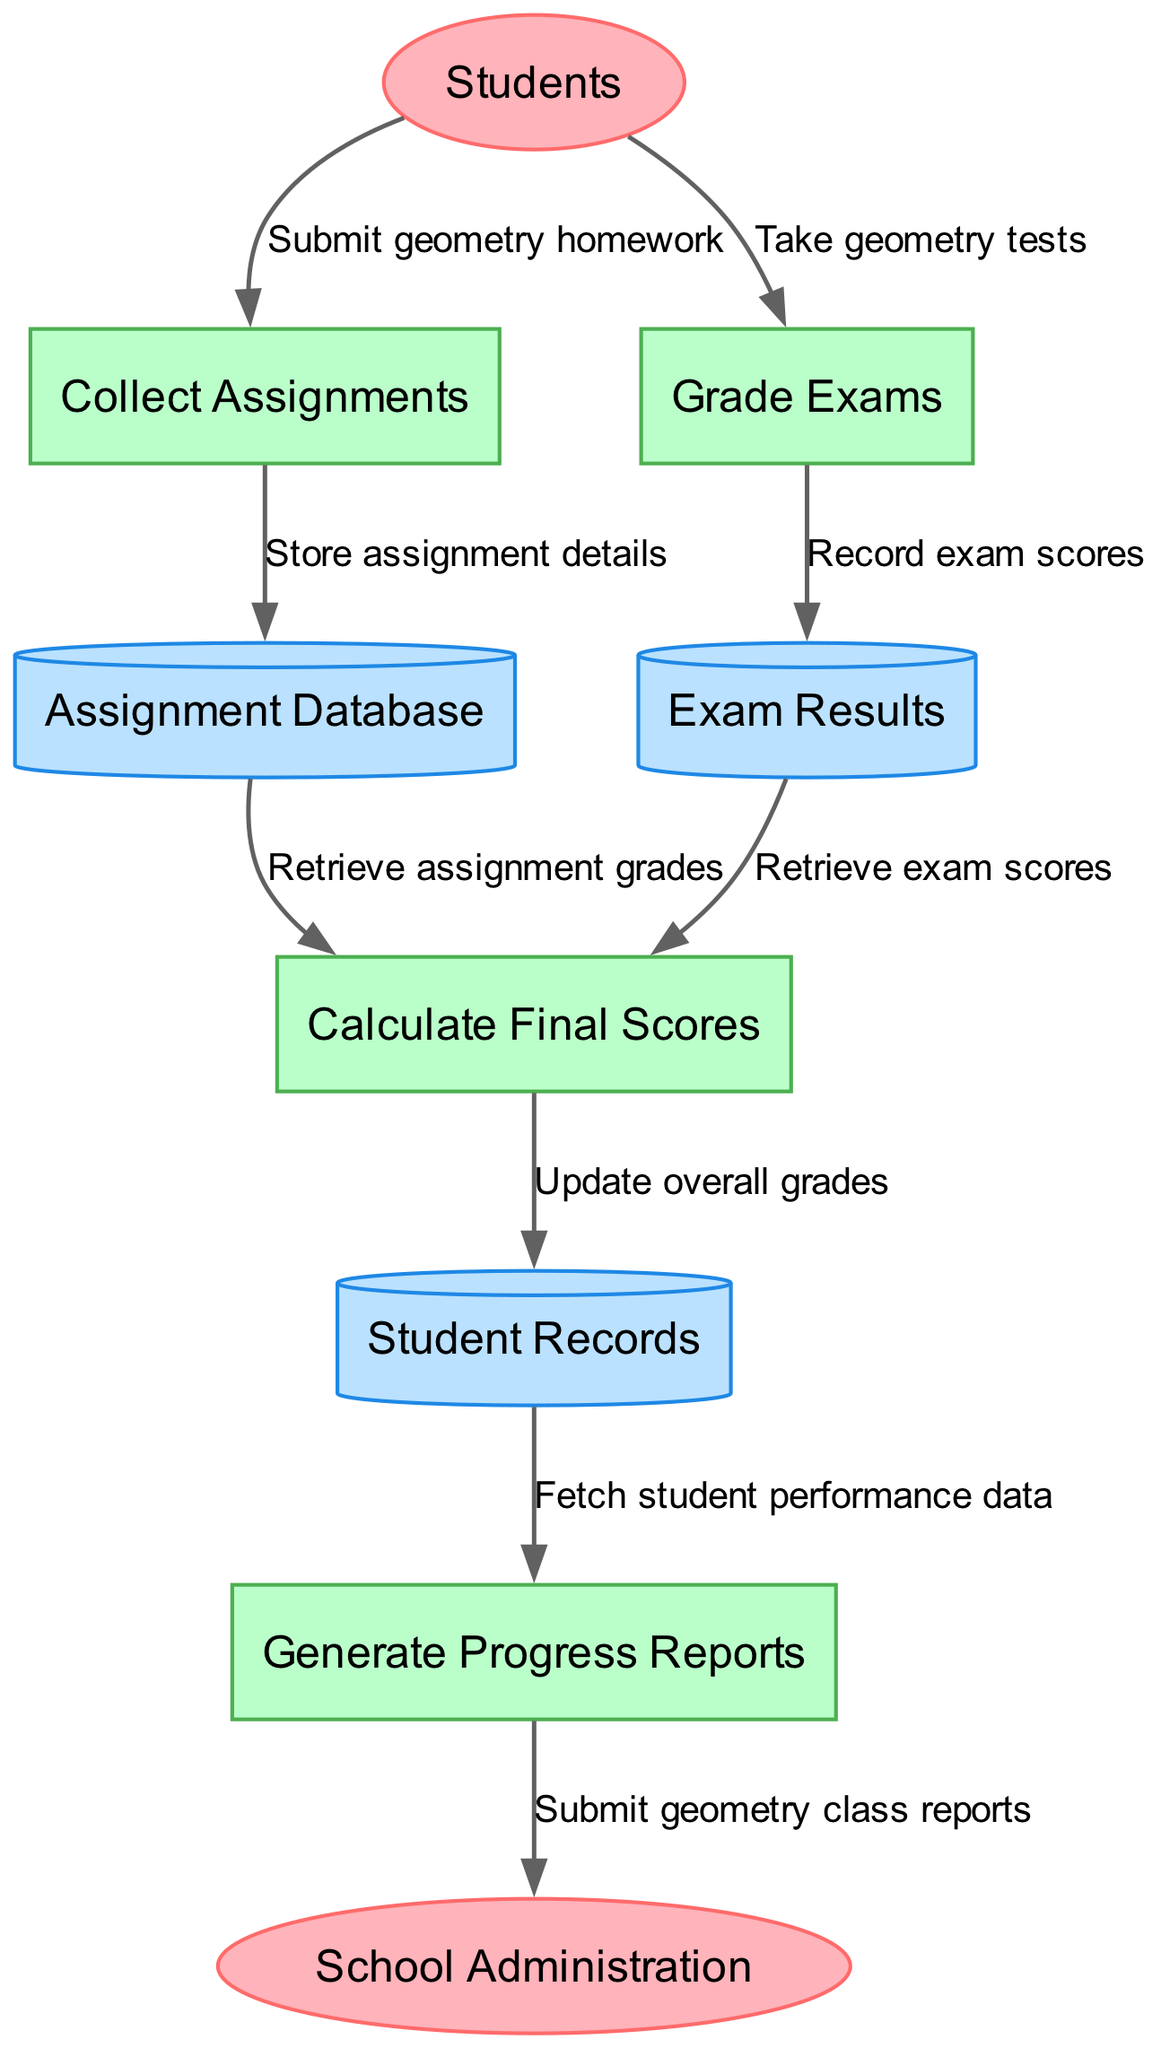What are the external entities in the diagram? The external entities listed in the diagram are "Students" and "School Administration." These represent the entities that interact with the grading system.
Answer: Students, School Administration How many processes are shown in the diagram? The diagram features four processes: "Collect Assignments," "Grade Exams," "Calculate Final Scores," and "Generate Progress Reports." This count is derived directly from the list of processes.
Answer: 4 What is the purpose of the "Collect Assignments" process? The "Collect Assignments" process is designated to gather submissions from students. The flow indicates that students submit their geometry homework to this process.
Answer: Gather submissions How does information flow from "Grade Exams" to "Exam Results"? The flow is a direct connection where "Grade Exams" records exam scores and passes them to "Exam Results." This indicates a data management step where scores are documented.
Answer: Record exam scores What happens after "Calculate Final Scores" receives data from "Assignment Database"? After receiving data from "Assignment Database," the "Calculate Final Scores" process retrieves assignment grades and combines them with exam results to update overall grades in the "Student Records" data store.
Answer: Update overall grades What do the arrows in the diagram represent? The arrows represent data flows between nodes, indicating how information moves from external entities, through processes, to data stores, effectively mapping the workflow.
Answer: Data flows Which process generates reports for the school administration? The "Generate Progress Reports" process is responsible for creating and submitting geometry class reports to the school administration, indicating a communication of student performance.
Answer: Generate Progress Reports What data does the "Generate Progress Reports" process fetch? The "Generate Progress Reports" process fetches student performance data from the "Student Records," which provides the necessary information to generate reports on student progress.
Answer: Fetch student performance data What kind of data store is "Assignment Database"? The "Assignment Database" is classified as a data store, specifically a cylinder shape in the diagram, which indicates that it is used to store assignment details gathered from student submissions.
Answer: Data store How does "Calculate Final Scores" use data from "Exam Results"? The process "Calculate Final Scores" retrieves exam scores from "Exam Results" to incorporate into the overall grade calculation, combining this data with retrieved assignment grades.
Answer: Retrieve exam scores 